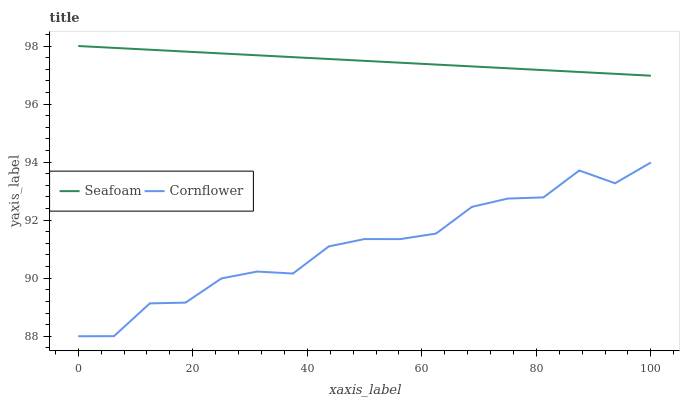Does Cornflower have the minimum area under the curve?
Answer yes or no. Yes. Does Seafoam have the maximum area under the curve?
Answer yes or no. Yes. Does Seafoam have the minimum area under the curve?
Answer yes or no. No. Is Seafoam the smoothest?
Answer yes or no. Yes. Is Cornflower the roughest?
Answer yes or no. Yes. Is Seafoam the roughest?
Answer yes or no. No. Does Cornflower have the lowest value?
Answer yes or no. Yes. Does Seafoam have the lowest value?
Answer yes or no. No. Does Seafoam have the highest value?
Answer yes or no. Yes. Is Cornflower less than Seafoam?
Answer yes or no. Yes. Is Seafoam greater than Cornflower?
Answer yes or no. Yes. Does Cornflower intersect Seafoam?
Answer yes or no. No. 